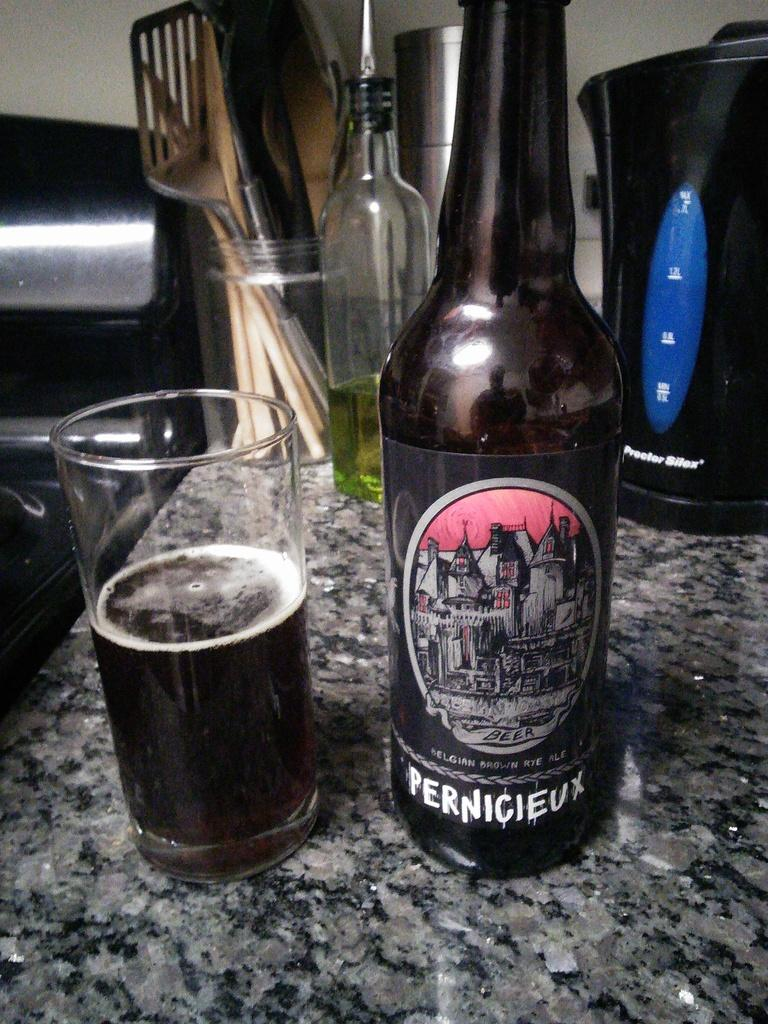<image>
Offer a succinct explanation of the picture presented. the word pernicieux that is on a bottle 